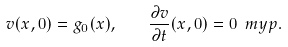Convert formula to latex. <formula><loc_0><loc_0><loc_500><loc_500>v ( x , 0 ) = g _ { 0 } ( x ) , \quad \frac { \partial v } { \partial t } ( x , 0 ) = 0 \ m y p .</formula> 